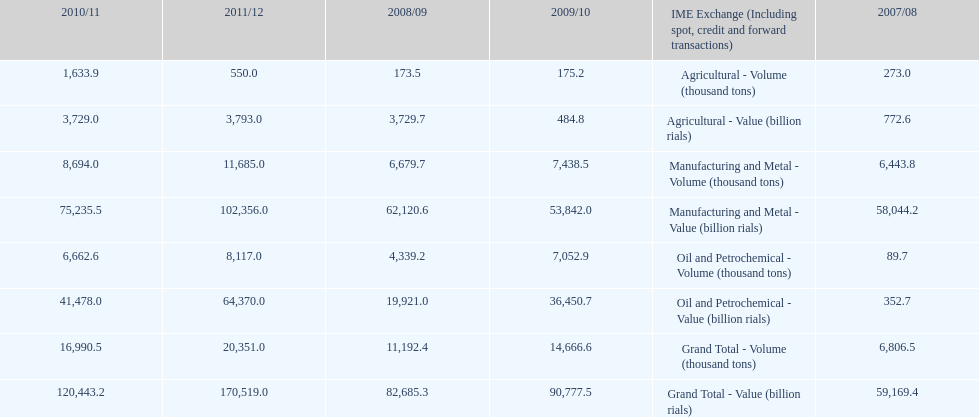What is the total agricultural value in 2008/09? 3,729.7. 